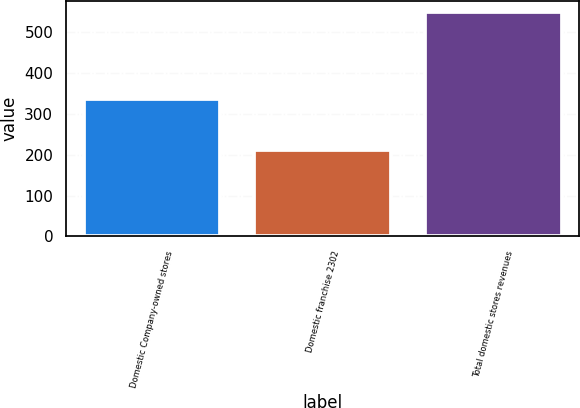Convert chart. <chart><loc_0><loc_0><loc_500><loc_500><bar_chart><fcel>Domestic Company-owned stores<fcel>Domestic franchise 2302<fcel>Total domestic stores revenues<nl><fcel>337.4<fcel>212.4<fcel>549.8<nl></chart> 